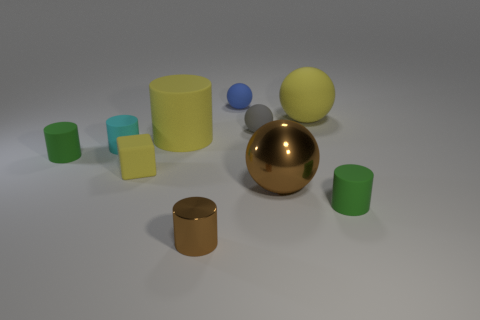Subtract all brown cylinders. How many cylinders are left? 4 Subtract all yellow cylinders. How many cylinders are left? 4 Subtract 1 spheres. How many spheres are left? 3 Subtract all red cylinders. Subtract all gray blocks. How many cylinders are left? 5 Subtract all spheres. How many objects are left? 6 Subtract all small gray spheres. Subtract all tiny gray matte things. How many objects are left? 8 Add 9 gray spheres. How many gray spheres are left? 10 Add 9 yellow matte spheres. How many yellow matte spheres exist? 10 Subtract 0 gray cylinders. How many objects are left? 10 